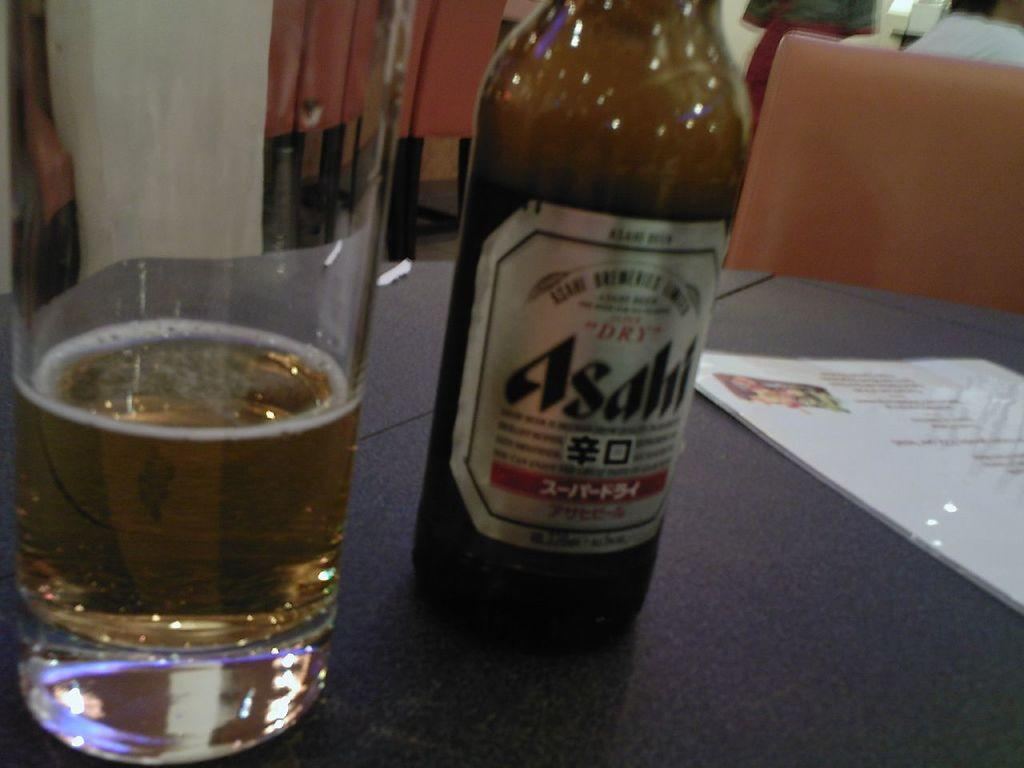Provide a one-sentence caption for the provided image. A bottle of Asahl next to a glass. 